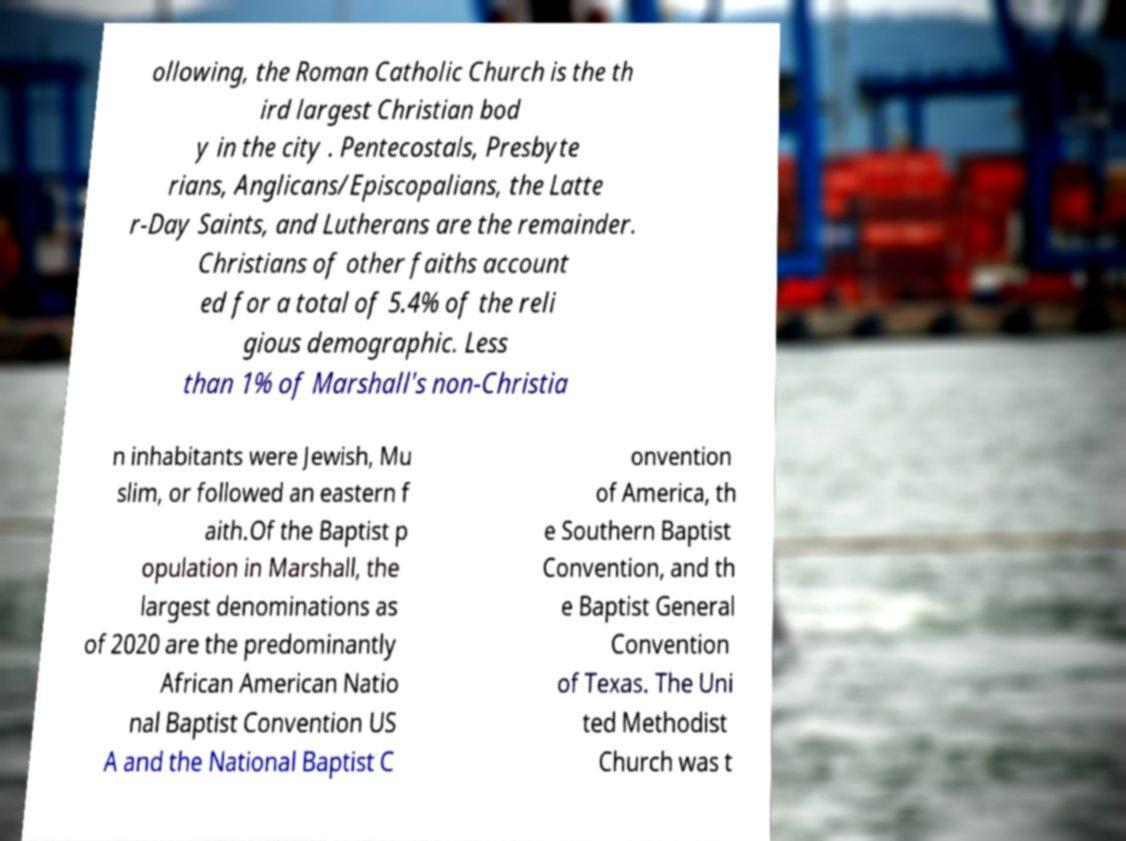Please identify and transcribe the text found in this image. ollowing, the Roman Catholic Church is the th ird largest Christian bod y in the city . Pentecostals, Presbyte rians, Anglicans/Episcopalians, the Latte r-Day Saints, and Lutherans are the remainder. Christians of other faiths account ed for a total of 5.4% of the reli gious demographic. Less than 1% of Marshall's non-Christia n inhabitants were Jewish, Mu slim, or followed an eastern f aith.Of the Baptist p opulation in Marshall, the largest denominations as of 2020 are the predominantly African American Natio nal Baptist Convention US A and the National Baptist C onvention of America, th e Southern Baptist Convention, and th e Baptist General Convention of Texas. The Uni ted Methodist Church was t 